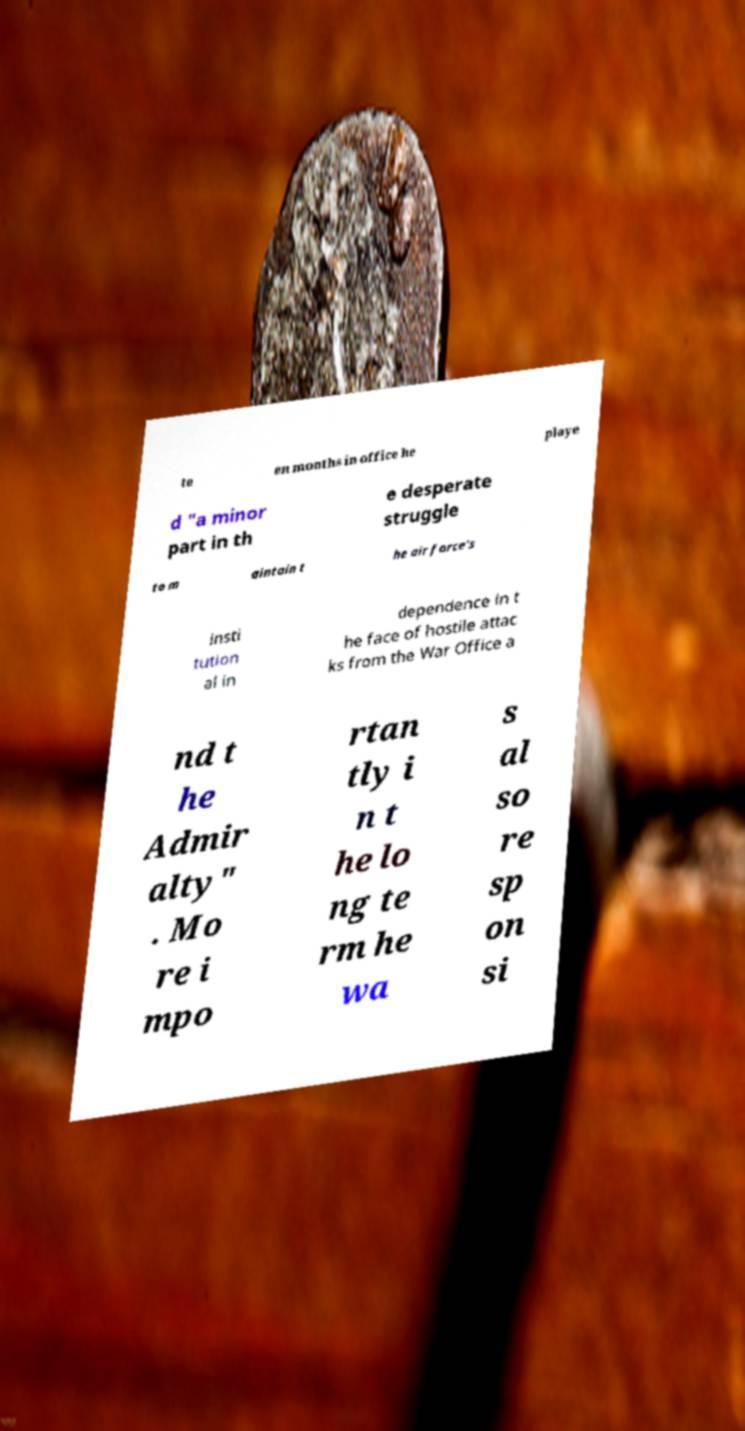Could you assist in decoding the text presented in this image and type it out clearly? te en months in office he playe d "a minor part in th e desperate struggle to m aintain t he air force's insti tution al in dependence in t he face of hostile attac ks from the War Office a nd t he Admir alty" . Mo re i mpo rtan tly i n t he lo ng te rm he wa s al so re sp on si 